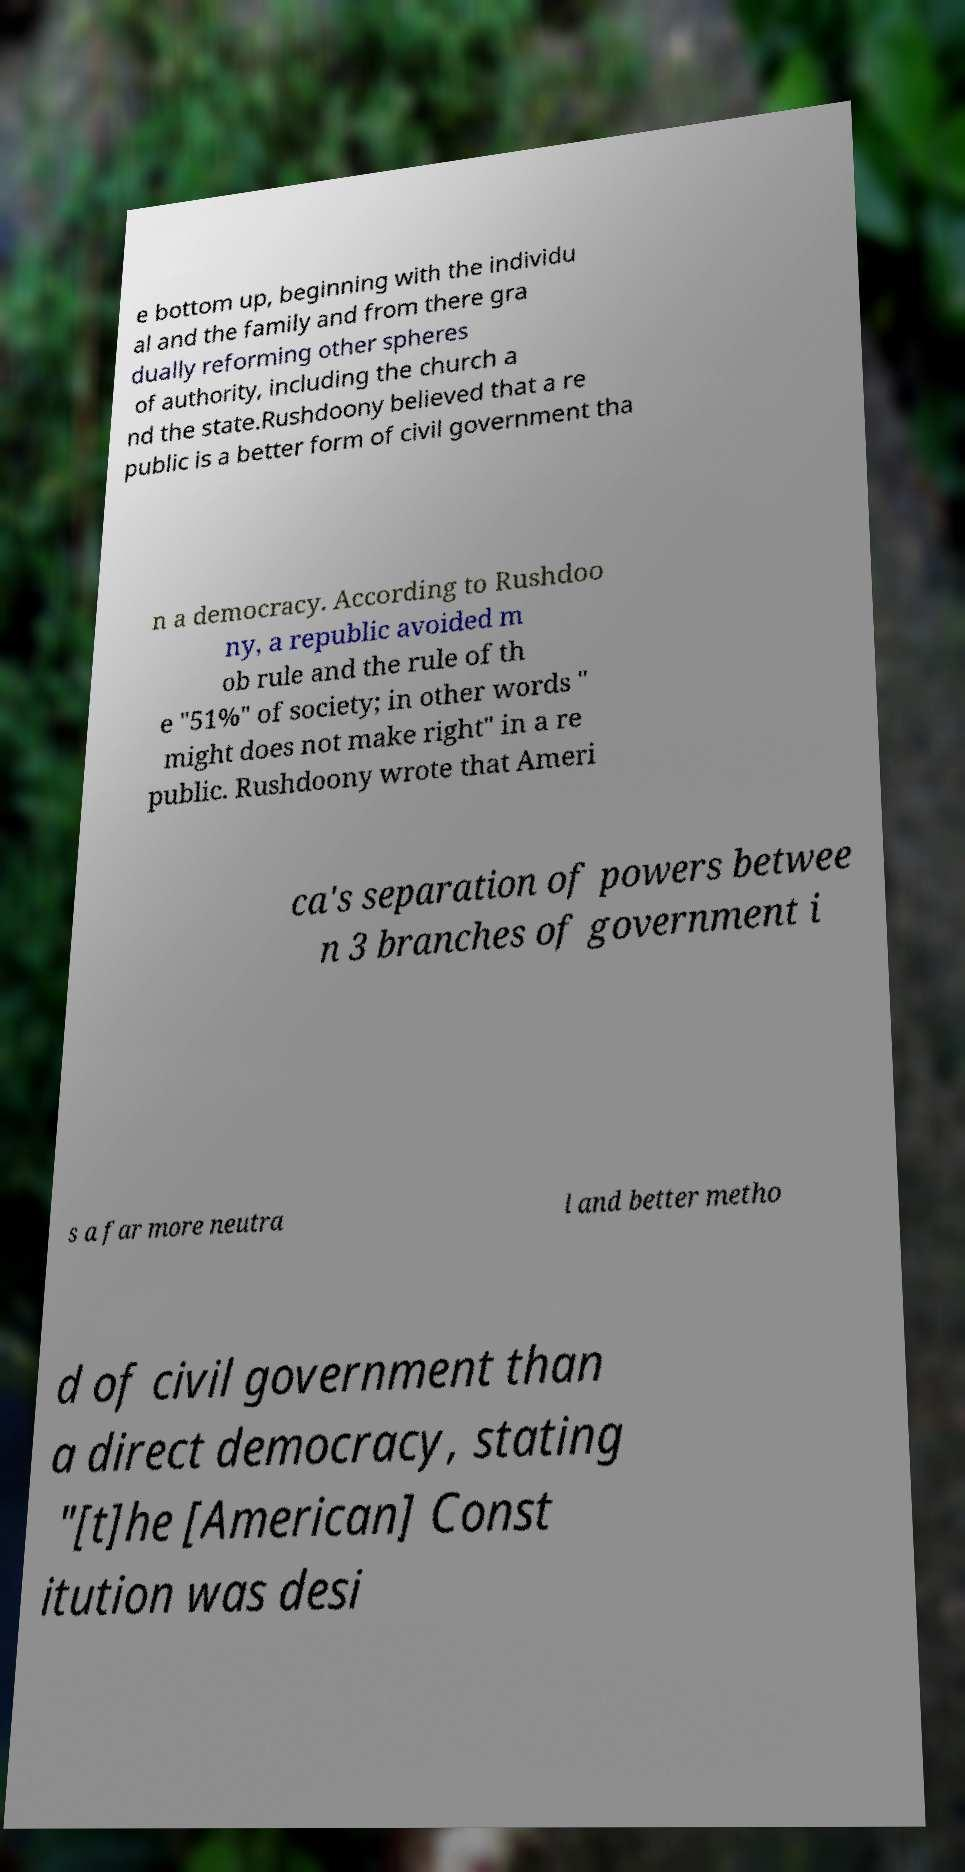I need the written content from this picture converted into text. Can you do that? e bottom up, beginning with the individu al and the family and from there gra dually reforming other spheres of authority, including the church a nd the state.Rushdoony believed that a re public is a better form of civil government tha n a democracy. According to Rushdoo ny, a republic avoided m ob rule and the rule of th e "51%" of society; in other words " might does not make right" in a re public. Rushdoony wrote that Ameri ca's separation of powers betwee n 3 branches of government i s a far more neutra l and better metho d of civil government than a direct democracy, stating "[t]he [American] Const itution was desi 